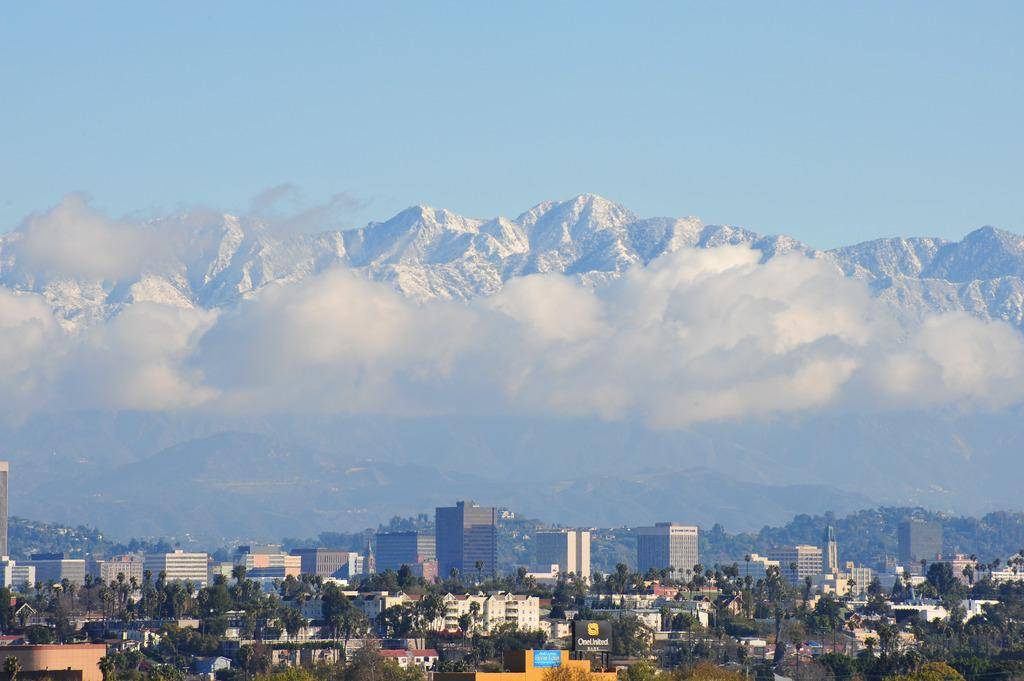What type of structures can be seen in the image? There are many buildings in the image. What other natural elements are present in the image? There are trees in the image. What can be seen in the distance in the background of the image? There is a snow mountain in the background of the image. What else is visible in the sky in the background of the image? Clouds are visible in the background of the image. Can you tell me which hospital is located in the image? There is no hospital mentioned or visible in the image. How does the snow mountain affect the breath of the trees in the image? The image does not show any trees' breath, and the snow mountain's presence does not affect it. 